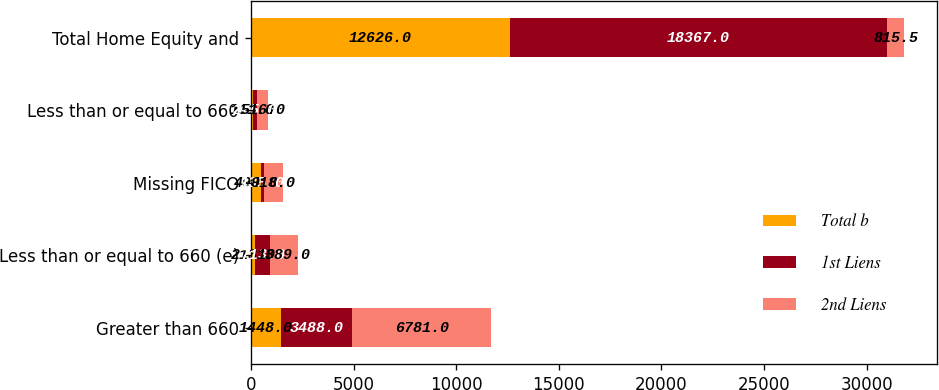<chart> <loc_0><loc_0><loc_500><loc_500><stacked_bar_chart><ecel><fcel>Greater than 660<fcel>Less than or equal to 660 (e)<fcel>Missing FICO<fcel>Less than or equal to 660<fcel>Total Home Equity and<nl><fcel>Total b<fcel>1448<fcel>213<fcel>494<fcel>111<fcel>12626<nl><fcel>1st Liens<fcel>3488<fcel>713<fcel>135<fcel>205<fcel>18367<nl><fcel>2nd Liens<fcel>6781<fcel>1389<fcel>918<fcel>516<fcel>815.5<nl></chart> 